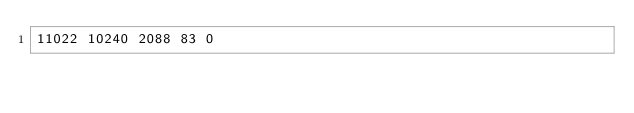Convert code to text. <code><loc_0><loc_0><loc_500><loc_500><_SML_>11022 10240 2088 83 0</code> 